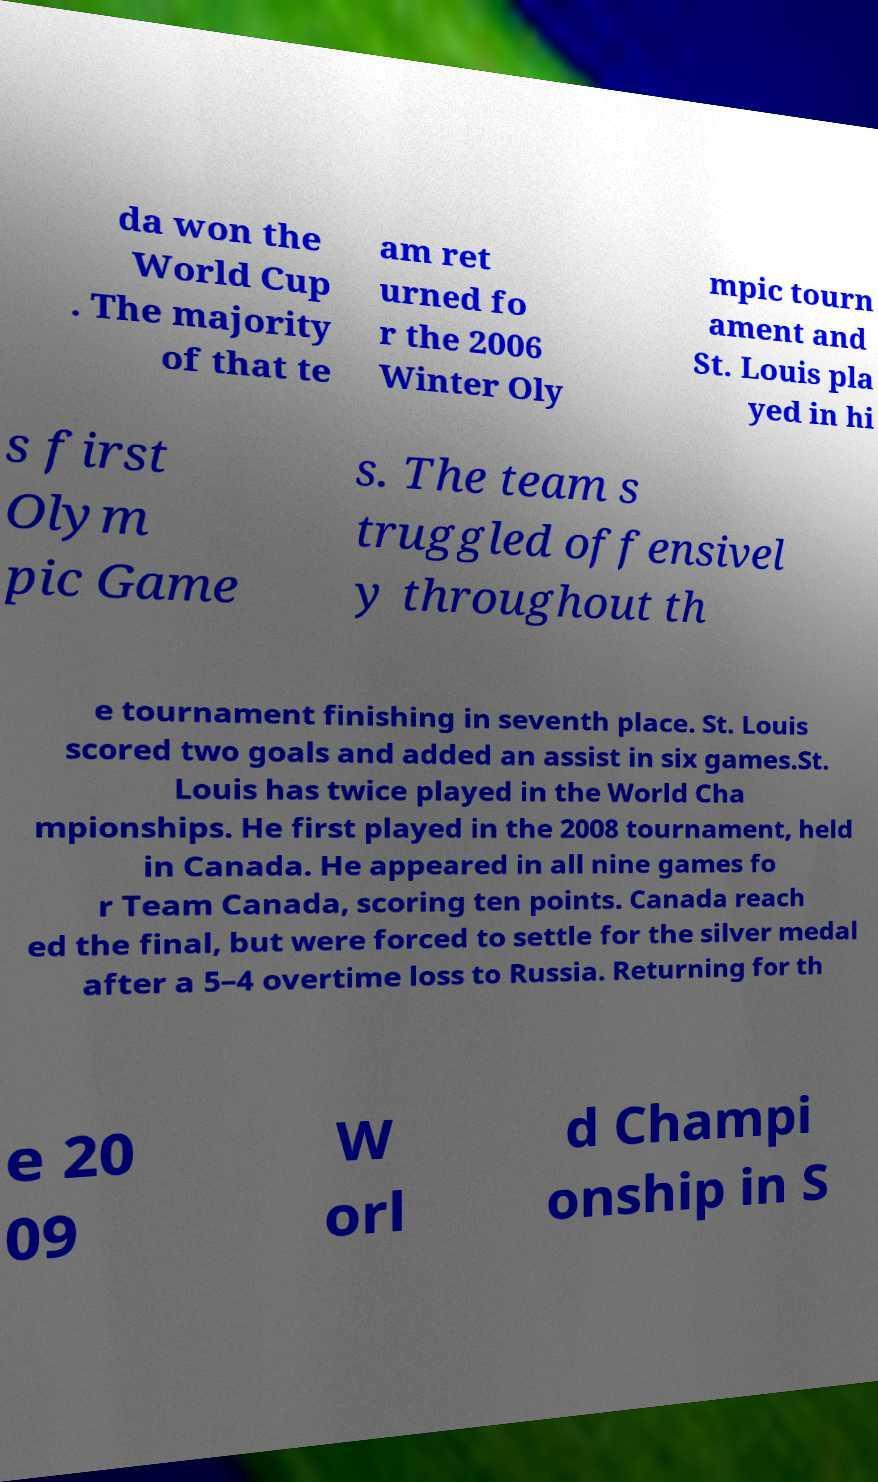Please identify and transcribe the text found in this image. da won the World Cup . The majority of that te am ret urned fo r the 2006 Winter Oly mpic tourn ament and St. Louis pla yed in hi s first Olym pic Game s. The team s truggled offensivel y throughout th e tournament finishing in seventh place. St. Louis scored two goals and added an assist in six games.St. Louis has twice played in the World Cha mpionships. He first played in the 2008 tournament, held in Canada. He appeared in all nine games fo r Team Canada, scoring ten points. Canada reach ed the final, but were forced to settle for the silver medal after a 5–4 overtime loss to Russia. Returning for th e 20 09 W orl d Champi onship in S 